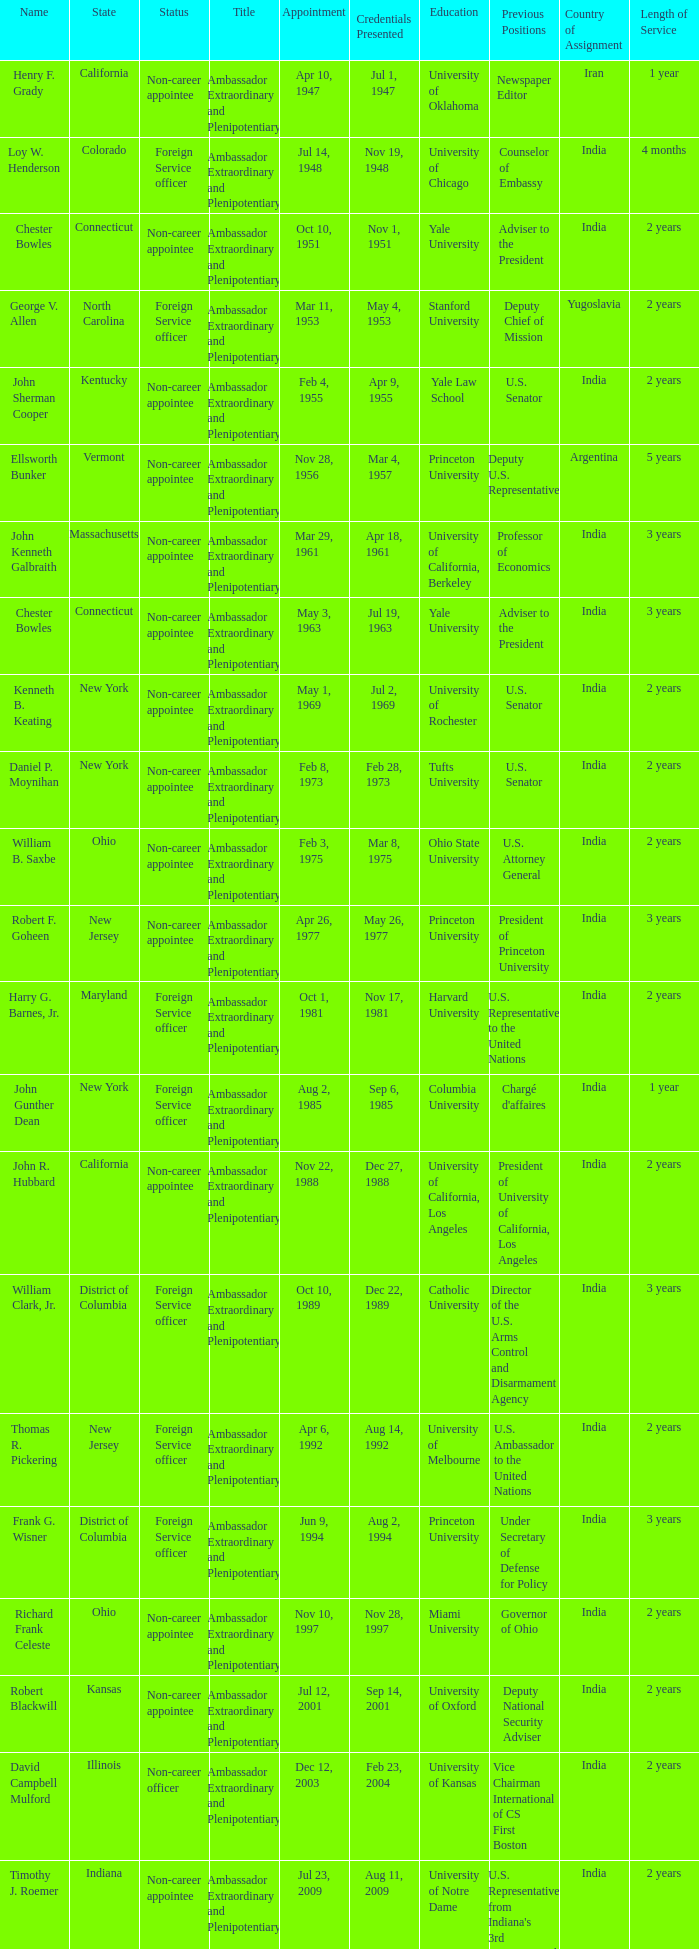What day was the appointment when Credentials Presented was jul 2, 1969? May 1, 1969. 